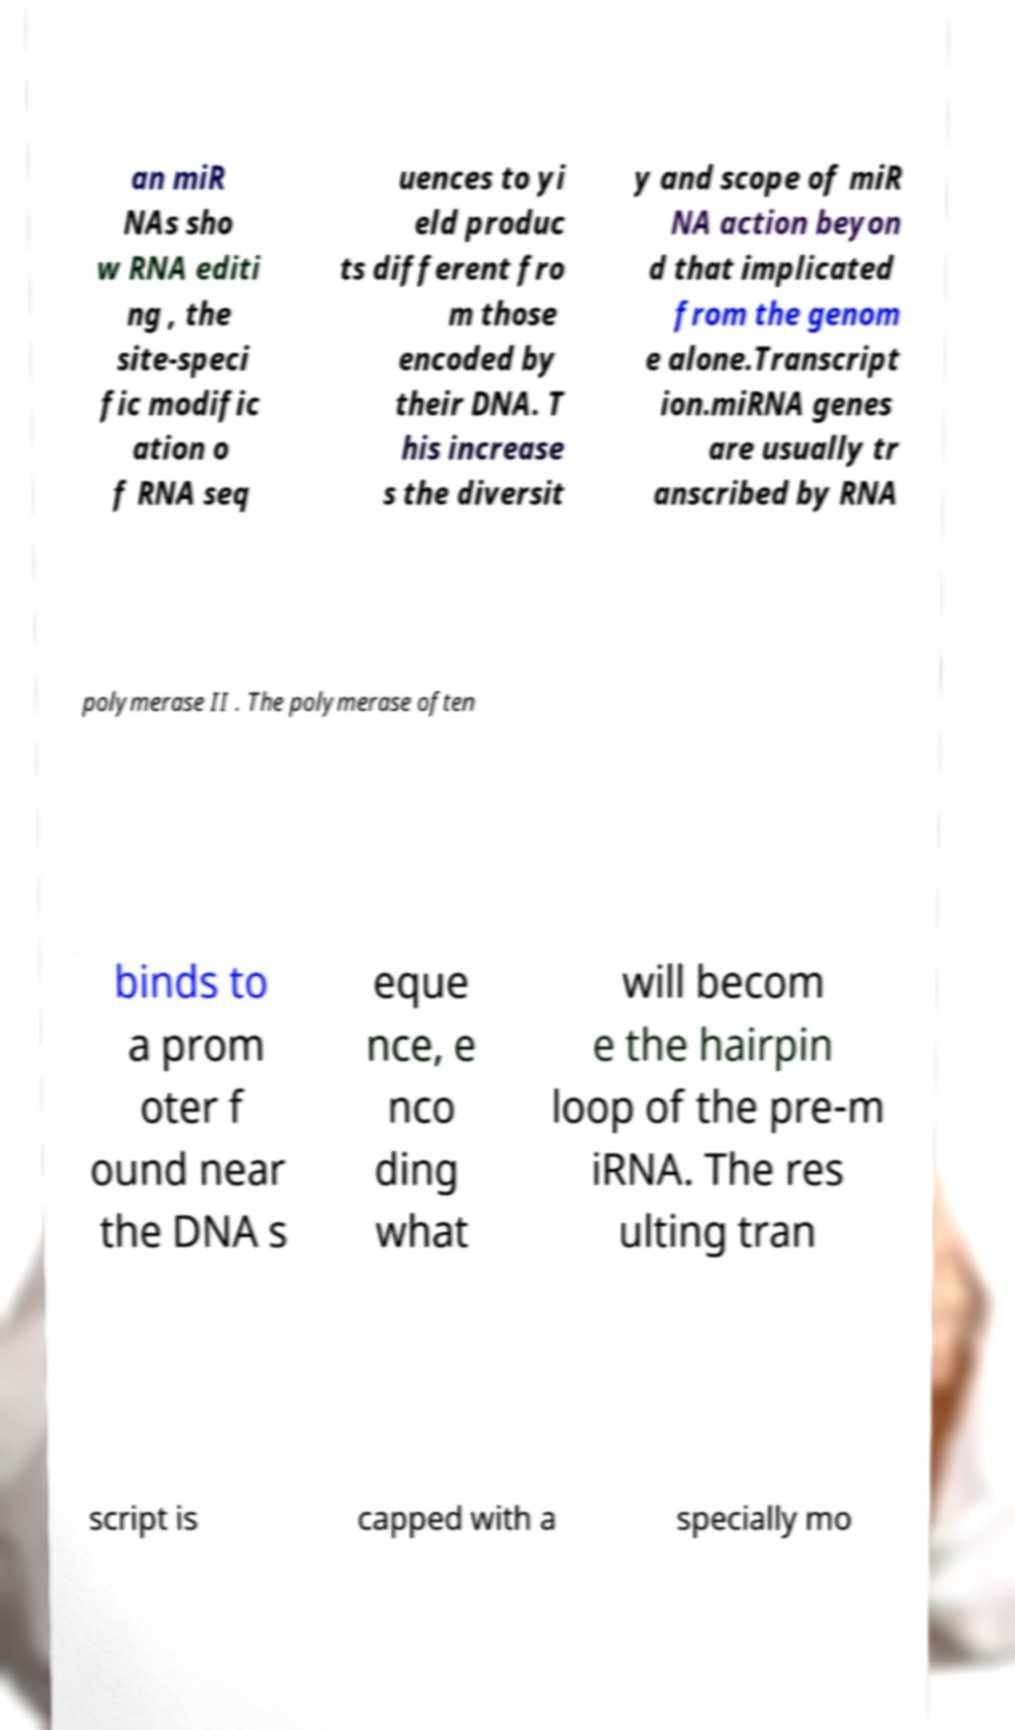Can you read and provide the text displayed in the image?This photo seems to have some interesting text. Can you extract and type it out for me? an miR NAs sho w RNA editi ng , the site-speci fic modific ation o f RNA seq uences to yi eld produc ts different fro m those encoded by their DNA. T his increase s the diversit y and scope of miR NA action beyon d that implicated from the genom e alone.Transcript ion.miRNA genes are usually tr anscribed by RNA polymerase II . The polymerase often binds to a prom oter f ound near the DNA s eque nce, e nco ding what will becom e the hairpin loop of the pre-m iRNA. The res ulting tran script is capped with a specially mo 